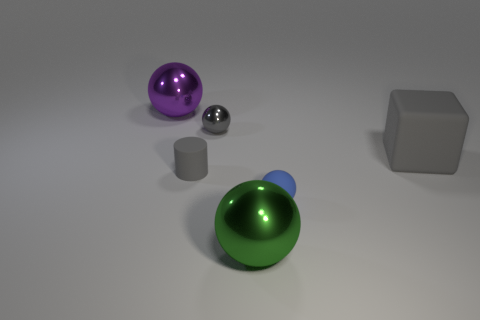Can you describe the other objects in the image apart from the green shiny ball? Certainly! Apart from the green shiny ball, there is a large purple shiny ball, a small shiny metal sphere, and two geometric solids - a gray cube and a smaller metallic cylinder. 